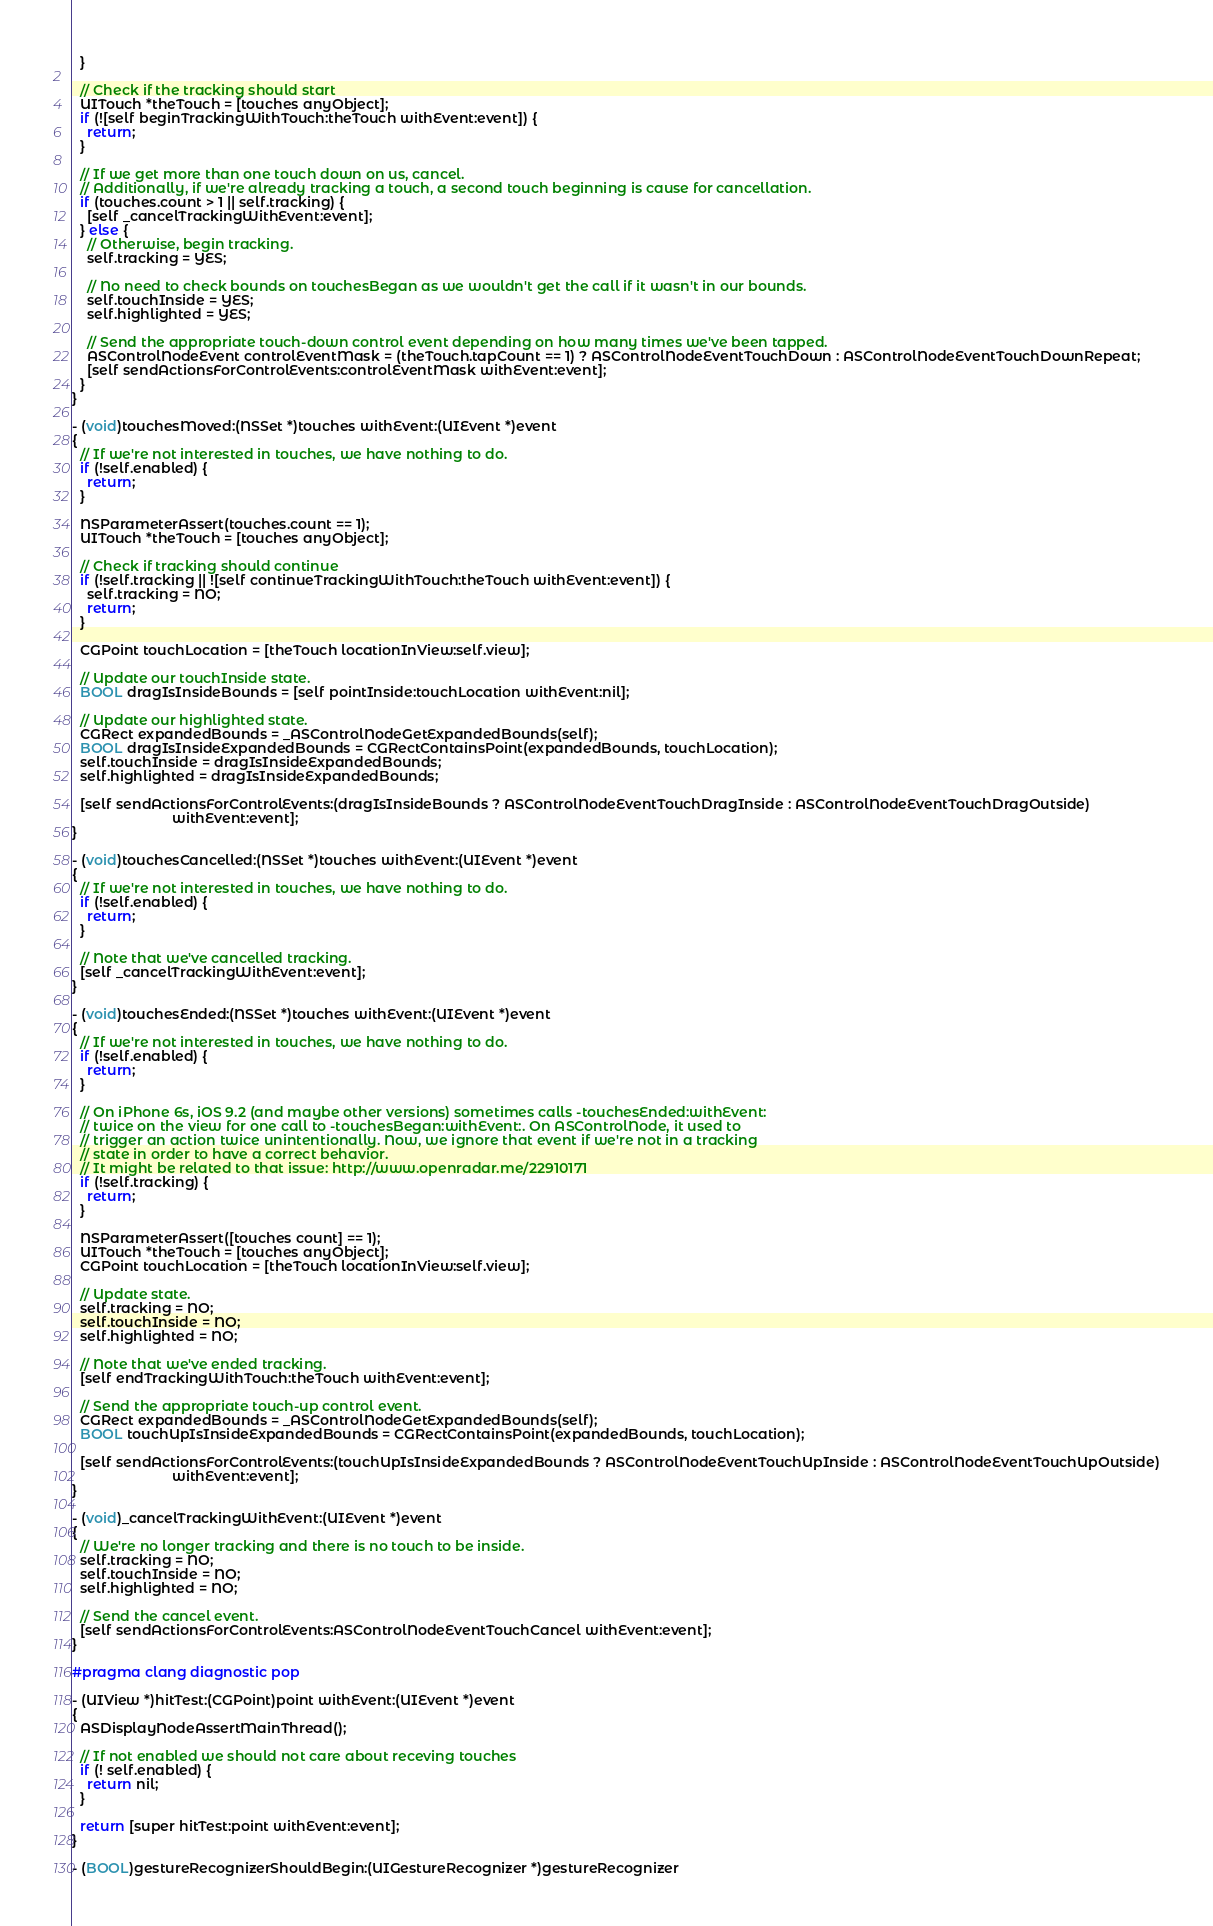Convert code to text. <code><loc_0><loc_0><loc_500><loc_500><_ObjectiveC_>  }
  
  // Check if the tracking should start
  UITouch *theTouch = [touches anyObject];
  if (![self beginTrackingWithTouch:theTouch withEvent:event]) {
    return;
  }

  // If we get more than one touch down on us, cancel.
  // Additionally, if we're already tracking a touch, a second touch beginning is cause for cancellation.
  if (touches.count > 1 || self.tracking) {
    [self _cancelTrackingWithEvent:event];
  } else {
    // Otherwise, begin tracking.
    self.tracking = YES;

    // No need to check bounds on touchesBegan as we wouldn't get the call if it wasn't in our bounds.
    self.touchInside = YES;
    self.highlighted = YES;

    // Send the appropriate touch-down control event depending on how many times we've been tapped.
    ASControlNodeEvent controlEventMask = (theTouch.tapCount == 1) ? ASControlNodeEventTouchDown : ASControlNodeEventTouchDownRepeat;
    [self sendActionsForControlEvents:controlEventMask withEvent:event];
  }
}

- (void)touchesMoved:(NSSet *)touches withEvent:(UIEvent *)event
{
  // If we're not interested in touches, we have nothing to do.
  if (!self.enabled) {
    return;
  }

  NSParameterAssert(touches.count == 1);
  UITouch *theTouch = [touches anyObject];
  
  // Check if tracking should continue
  if (!self.tracking || ![self continueTrackingWithTouch:theTouch withEvent:event]) {
    self.tracking = NO;
    return;
  }
  
  CGPoint touchLocation = [theTouch locationInView:self.view];

  // Update our touchInside state.
  BOOL dragIsInsideBounds = [self pointInside:touchLocation withEvent:nil];

  // Update our highlighted state.
  CGRect expandedBounds = _ASControlNodeGetExpandedBounds(self);
  BOOL dragIsInsideExpandedBounds = CGRectContainsPoint(expandedBounds, touchLocation);
  self.touchInside = dragIsInsideExpandedBounds;
  self.highlighted = dragIsInsideExpandedBounds;

  [self sendActionsForControlEvents:(dragIsInsideBounds ? ASControlNodeEventTouchDragInside : ASControlNodeEventTouchDragOutside)
                          withEvent:event];
}

- (void)touchesCancelled:(NSSet *)touches withEvent:(UIEvent *)event
{
  // If we're not interested in touches, we have nothing to do.
  if (!self.enabled) {
    return;
  }

  // Note that we've cancelled tracking.
  [self _cancelTrackingWithEvent:event];
}

- (void)touchesEnded:(NSSet *)touches withEvent:(UIEvent *)event
{
  // If we're not interested in touches, we have nothing to do.
  if (!self.enabled) {
    return;
  }

  // On iPhone 6s, iOS 9.2 (and maybe other versions) sometimes calls -touchesEnded:withEvent:
  // twice on the view for one call to -touchesBegan:withEvent:. On ASControlNode, it used to
  // trigger an action twice unintentionally. Now, we ignore that event if we're not in a tracking
  // state in order to have a correct behavior.
  // It might be related to that issue: http://www.openradar.me/22910171
  if (!self.tracking) {
    return;
  }

  NSParameterAssert([touches count] == 1);
  UITouch *theTouch = [touches anyObject];
  CGPoint touchLocation = [theTouch locationInView:self.view];

  // Update state.
  self.tracking = NO;
  self.touchInside = NO;
  self.highlighted = NO;

  // Note that we've ended tracking.
  [self endTrackingWithTouch:theTouch withEvent:event];

  // Send the appropriate touch-up control event.
  CGRect expandedBounds = _ASControlNodeGetExpandedBounds(self);
  BOOL touchUpIsInsideExpandedBounds = CGRectContainsPoint(expandedBounds, touchLocation);

  [self sendActionsForControlEvents:(touchUpIsInsideExpandedBounds ? ASControlNodeEventTouchUpInside : ASControlNodeEventTouchUpOutside)
                          withEvent:event];
}

- (void)_cancelTrackingWithEvent:(UIEvent *)event
{
  // We're no longer tracking and there is no touch to be inside.
  self.tracking = NO;
  self.touchInside = NO;
  self.highlighted = NO;
  
  // Send the cancel event.
  [self sendActionsForControlEvents:ASControlNodeEventTouchCancel withEvent:event];
}

#pragma clang diagnostic pop

- (UIView *)hitTest:(CGPoint)point withEvent:(UIEvent *)event
{
  ASDisplayNodeAssertMainThread();

  // If not enabled we should not care about receving touches
  if (! self.enabled) {
    return nil;
  }

  return [super hitTest:point withEvent:event];
}

- (BOOL)gestureRecognizerShouldBegin:(UIGestureRecognizer *)gestureRecognizer</code> 